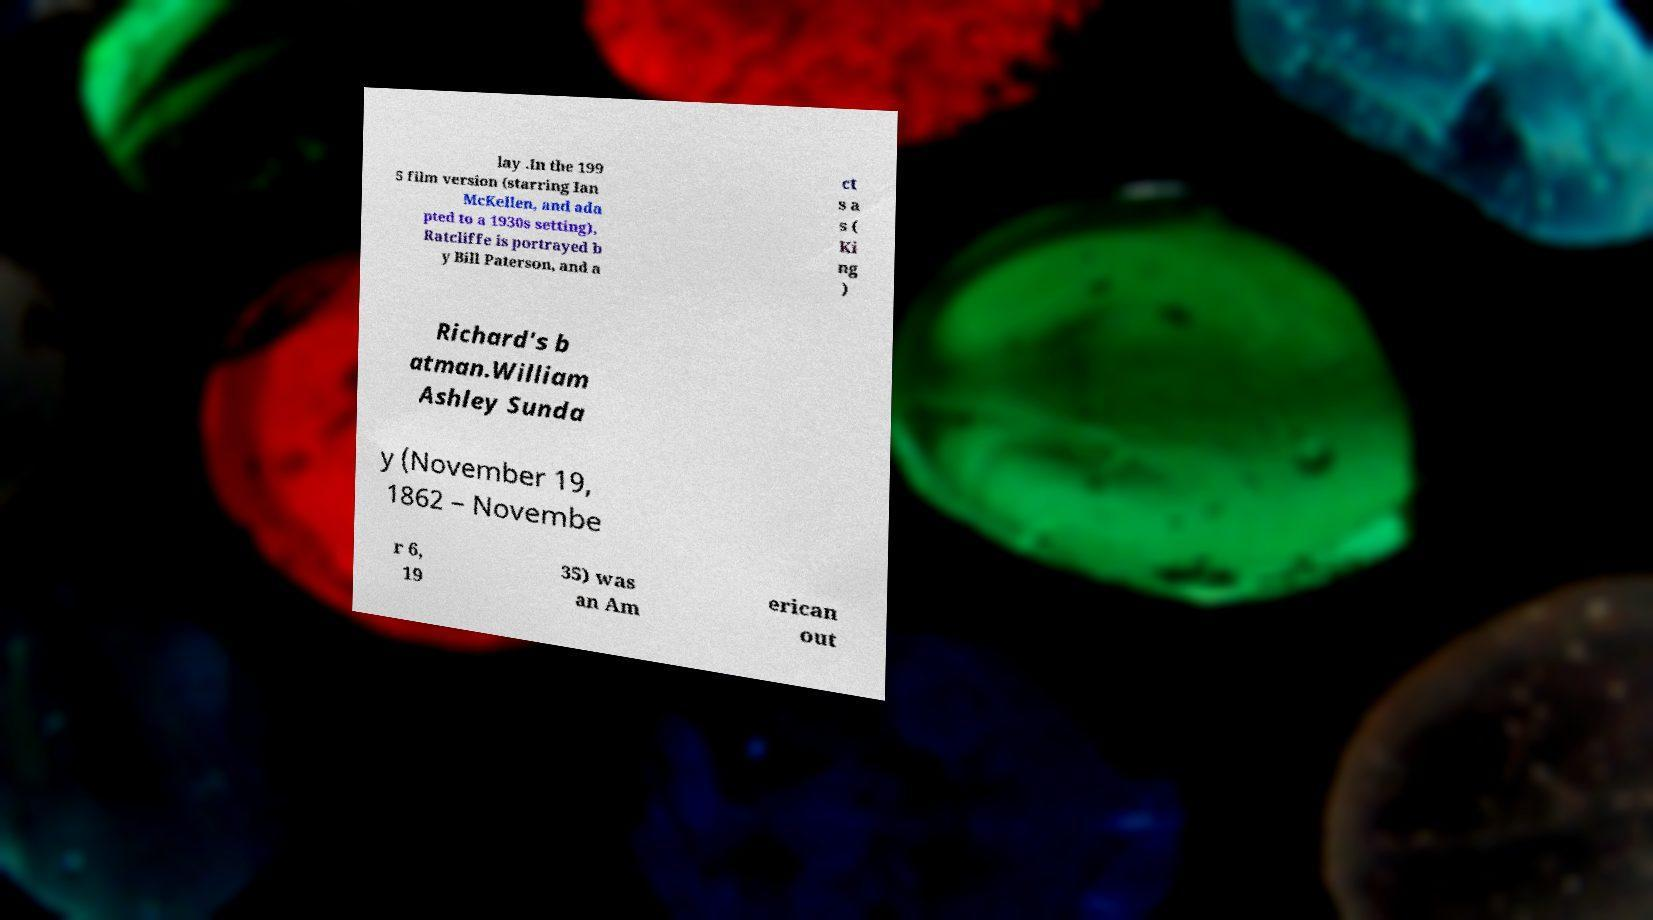There's text embedded in this image that I need extracted. Can you transcribe it verbatim? lay .In the 199 5 film version (starring Ian McKellen, and ada pted to a 1930s setting), Ratcliffe is portrayed b y Bill Paterson, and a ct s a s ( Ki ng ) Richard's b atman.William Ashley Sunda y (November 19, 1862 – Novembe r 6, 19 35) was an Am erican out 